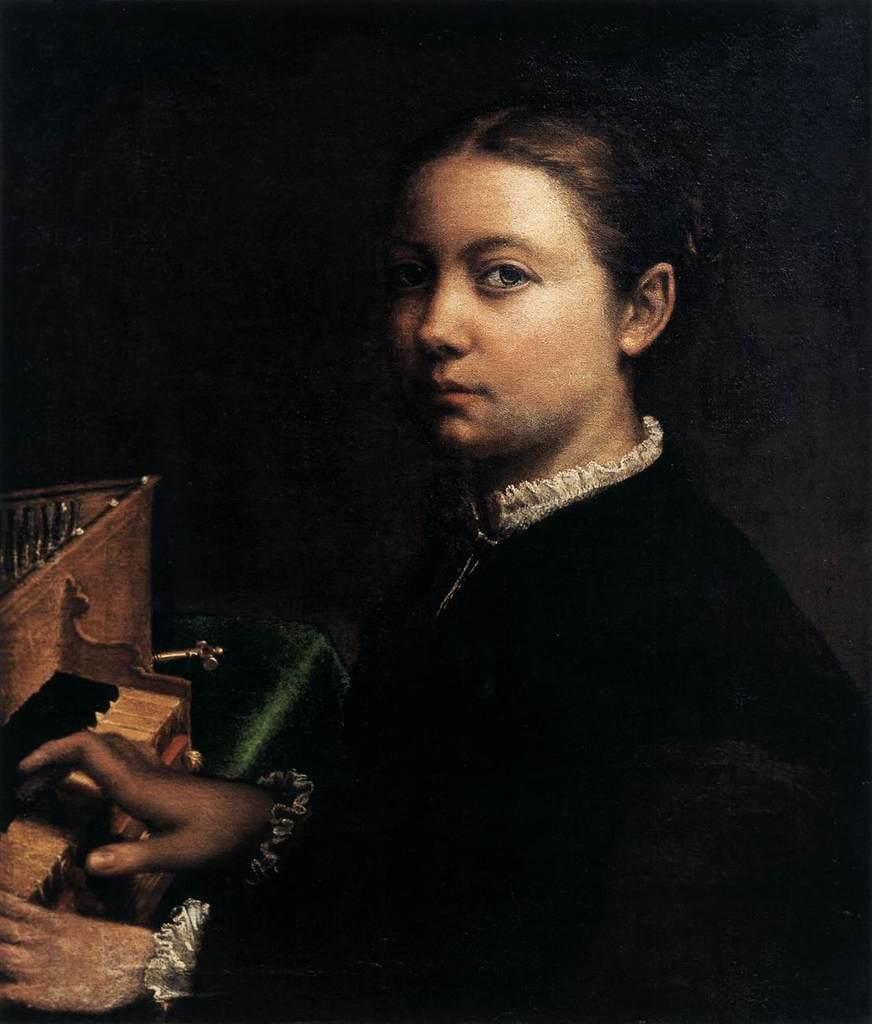What is the main subject of the image? There is a photo of a woman in the image. What is the woman doing in the photo? The woman is playing the piano. Can you describe the background of the image? There is a dark background in the image. How many beds are visible in the image? There are no beds present in the image; it features a photo of a woman playing the piano against a dark background. 